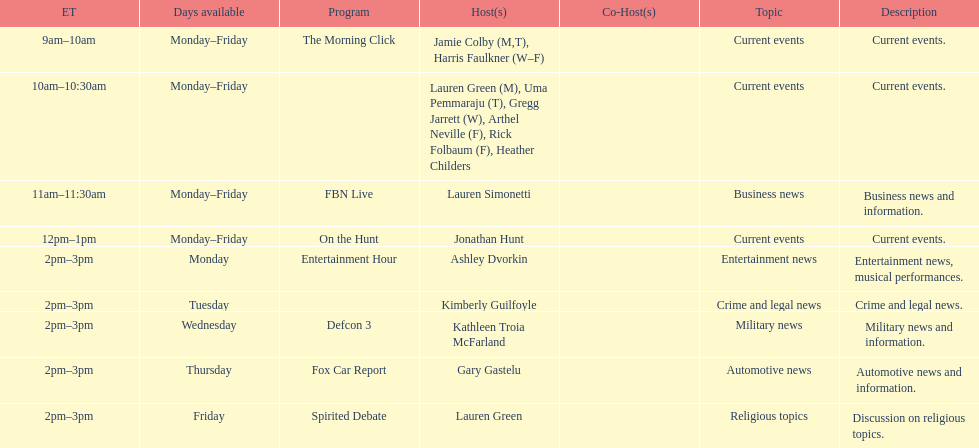What is the first show to play on monday mornings? The Morning Click. 